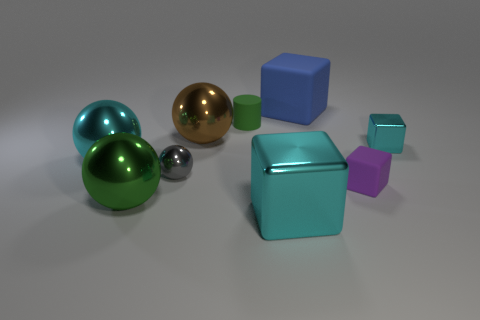How many green shiny things have the same size as the gray metallic sphere?
Your answer should be very brief. 0. Do the small cylinder and the cyan thing to the right of the blue matte object have the same material?
Offer a very short reply. No. Is the number of small matte blocks less than the number of tiny metal objects?
Keep it short and to the point. Yes. Is there any other thing that has the same color as the tiny metallic ball?
Give a very brief answer. No. What shape is the tiny cyan thing that is made of the same material as the brown object?
Provide a short and direct response. Cube. There is a tiny metallic thing that is right of the block that is in front of the large green shiny sphere; how many cyan objects are in front of it?
Your answer should be very brief. 2. What shape is the small object that is both left of the blue matte thing and in front of the large brown object?
Provide a short and direct response. Sphere. Are there fewer blue objects on the left side of the cyan ball than large brown metallic objects?
Provide a short and direct response. Yes. What number of large things are either gray metallic objects or matte cylinders?
Ensure brevity in your answer.  0. What is the size of the green ball?
Keep it short and to the point. Large. 